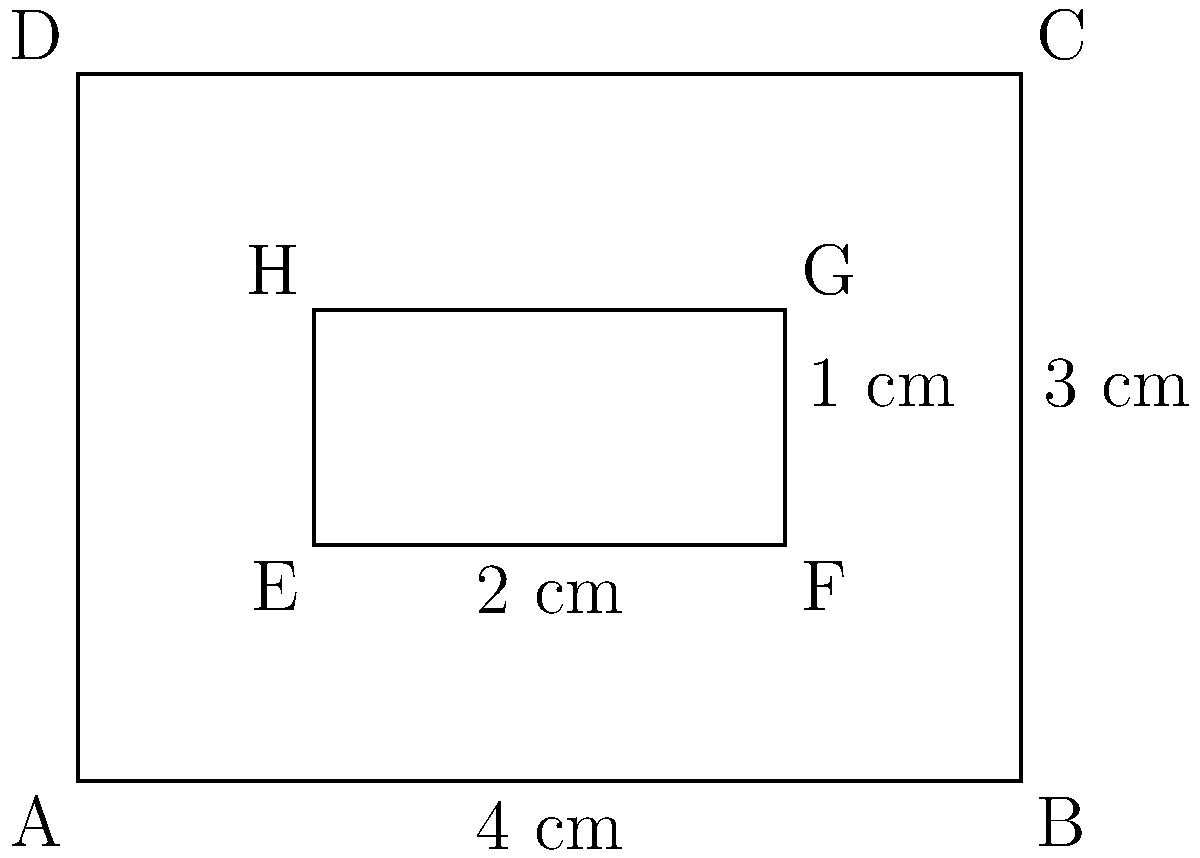A robotic hand with articulated fingers is designed to cover a rectangular area. The outer rectangle ABCD represents the maximum coverage area, while the inner rectangle EFGH represents the area covered by the fingers when partially closed. If AB = 4 cm, BC = 3 cm, EF = 2 cm, and FG = 1 cm, what percentage of the maximum coverage area is still exposed when the fingers are partially closed? To solve this problem, we need to follow these steps:

1. Calculate the area of the outer rectangle (ABCD):
   $$A_{ABCD} = AB \times BC = 4 \text{ cm} \times 3 \text{ cm} = 12 \text{ cm}^2$$

2. Calculate the area of the inner rectangle (EFGH):
   $$A_{EFGH} = EF \times FG = 2 \text{ cm} \times 1 \text{ cm} = 2 \text{ cm}^2$$

3. Calculate the exposed area:
   $$A_{exposed} = A_{ABCD} - A_{EFGH} = 12 \text{ cm}^2 - 2 \text{ cm}^2 = 10 \text{ cm}^2$$

4. Calculate the percentage of the exposed area:
   $$\text{Percentage exposed} = \frac{A_{exposed}}{A_{ABCD}} \times 100\% = \frac{10 \text{ cm}^2}{12 \text{ cm}^2} \times 100\% = \frac{5}{6} \times 100\% \approx 83.33\%$$

Therefore, approximately 83.33% of the maximum coverage area is still exposed when the fingers are partially closed.
Answer: 83.33% 